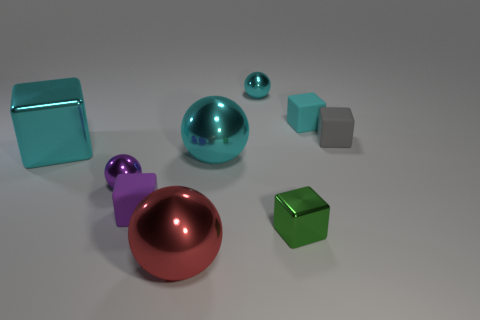Subtract all tiny green cubes. How many cubes are left? 4 Add 1 small green blocks. How many objects exist? 10 Subtract all spheres. How many objects are left? 5 Subtract all red spheres. How many spheres are left? 3 Subtract all small gray shiny balls. Subtract all small cyan metallic objects. How many objects are left? 8 Add 2 small purple metal objects. How many small purple metal objects are left? 3 Add 6 small cyan spheres. How many small cyan spheres exist? 7 Subtract 0 brown cylinders. How many objects are left? 9 Subtract 2 blocks. How many blocks are left? 3 Subtract all purple blocks. Subtract all gray balls. How many blocks are left? 4 